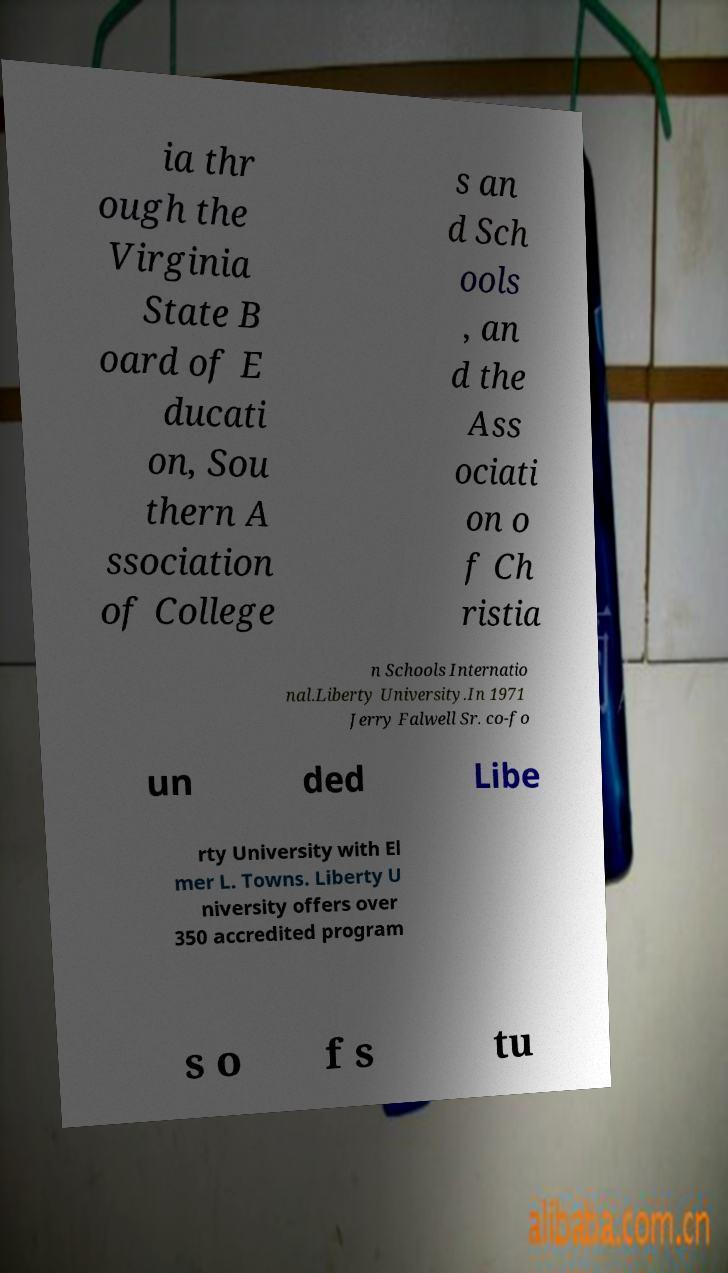Can you read and provide the text displayed in the image?This photo seems to have some interesting text. Can you extract and type it out for me? ia thr ough the Virginia State B oard of E ducati on, Sou thern A ssociation of College s an d Sch ools , an d the Ass ociati on o f Ch ristia n Schools Internatio nal.Liberty University.In 1971 Jerry Falwell Sr. co-fo un ded Libe rty University with El mer L. Towns. Liberty U niversity offers over 350 accredited program s o f s tu 